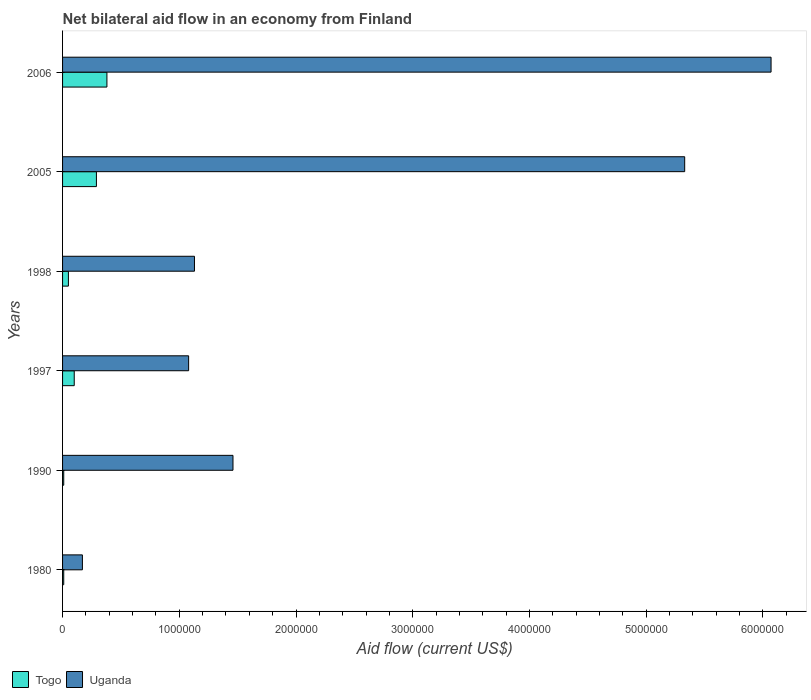How many bars are there on the 3rd tick from the bottom?
Ensure brevity in your answer.  2. What is the label of the 2nd group of bars from the top?
Give a very brief answer. 2005. In which year was the net bilateral aid flow in Uganda maximum?
Offer a terse response. 2006. In which year was the net bilateral aid flow in Togo minimum?
Offer a terse response. 1980. What is the total net bilateral aid flow in Togo in the graph?
Offer a very short reply. 8.40e+05. What is the difference between the net bilateral aid flow in Uganda in 1980 and that in 2005?
Keep it short and to the point. -5.16e+06. What is the average net bilateral aid flow in Uganda per year?
Your answer should be very brief. 2.54e+06. In the year 2005, what is the difference between the net bilateral aid flow in Uganda and net bilateral aid flow in Togo?
Provide a short and direct response. 5.04e+06. What is the ratio of the net bilateral aid flow in Togo in 1998 to that in 2005?
Give a very brief answer. 0.17. Is the net bilateral aid flow in Uganda in 1980 less than that in 1990?
Provide a succinct answer. Yes. Is the difference between the net bilateral aid flow in Uganda in 1997 and 2006 greater than the difference between the net bilateral aid flow in Togo in 1997 and 2006?
Provide a succinct answer. No. What is the difference between the highest and the second highest net bilateral aid flow in Uganda?
Give a very brief answer. 7.40e+05. What is the difference between the highest and the lowest net bilateral aid flow in Togo?
Offer a very short reply. 3.70e+05. Is the sum of the net bilateral aid flow in Togo in 1980 and 2005 greater than the maximum net bilateral aid flow in Uganda across all years?
Your answer should be very brief. No. What does the 1st bar from the top in 1990 represents?
Make the answer very short. Uganda. What does the 2nd bar from the bottom in 1998 represents?
Keep it short and to the point. Uganda. How many years are there in the graph?
Offer a terse response. 6. What is the difference between two consecutive major ticks on the X-axis?
Offer a very short reply. 1.00e+06. Does the graph contain any zero values?
Offer a very short reply. No. Where does the legend appear in the graph?
Ensure brevity in your answer.  Bottom left. How many legend labels are there?
Your answer should be very brief. 2. What is the title of the graph?
Ensure brevity in your answer.  Net bilateral aid flow in an economy from Finland. What is the label or title of the X-axis?
Your answer should be compact. Aid flow (current US$). What is the Aid flow (current US$) of Uganda in 1980?
Offer a very short reply. 1.70e+05. What is the Aid flow (current US$) in Togo in 1990?
Give a very brief answer. 10000. What is the Aid flow (current US$) in Uganda in 1990?
Make the answer very short. 1.46e+06. What is the Aid flow (current US$) of Uganda in 1997?
Your response must be concise. 1.08e+06. What is the Aid flow (current US$) of Togo in 1998?
Your answer should be compact. 5.00e+04. What is the Aid flow (current US$) of Uganda in 1998?
Your response must be concise. 1.13e+06. What is the Aid flow (current US$) in Togo in 2005?
Keep it short and to the point. 2.90e+05. What is the Aid flow (current US$) of Uganda in 2005?
Your answer should be compact. 5.33e+06. What is the Aid flow (current US$) of Togo in 2006?
Offer a very short reply. 3.80e+05. What is the Aid flow (current US$) of Uganda in 2006?
Ensure brevity in your answer.  6.07e+06. Across all years, what is the maximum Aid flow (current US$) of Uganda?
Offer a terse response. 6.07e+06. What is the total Aid flow (current US$) of Togo in the graph?
Provide a succinct answer. 8.40e+05. What is the total Aid flow (current US$) of Uganda in the graph?
Your answer should be very brief. 1.52e+07. What is the difference between the Aid flow (current US$) in Togo in 1980 and that in 1990?
Offer a terse response. 0. What is the difference between the Aid flow (current US$) in Uganda in 1980 and that in 1990?
Provide a short and direct response. -1.29e+06. What is the difference between the Aid flow (current US$) in Togo in 1980 and that in 1997?
Provide a short and direct response. -9.00e+04. What is the difference between the Aid flow (current US$) of Uganda in 1980 and that in 1997?
Ensure brevity in your answer.  -9.10e+05. What is the difference between the Aid flow (current US$) of Uganda in 1980 and that in 1998?
Give a very brief answer. -9.60e+05. What is the difference between the Aid flow (current US$) in Togo in 1980 and that in 2005?
Give a very brief answer. -2.80e+05. What is the difference between the Aid flow (current US$) in Uganda in 1980 and that in 2005?
Your answer should be very brief. -5.16e+06. What is the difference between the Aid flow (current US$) of Togo in 1980 and that in 2006?
Make the answer very short. -3.70e+05. What is the difference between the Aid flow (current US$) in Uganda in 1980 and that in 2006?
Your answer should be very brief. -5.90e+06. What is the difference between the Aid flow (current US$) of Uganda in 1990 and that in 1997?
Your response must be concise. 3.80e+05. What is the difference between the Aid flow (current US$) of Togo in 1990 and that in 1998?
Your answer should be compact. -4.00e+04. What is the difference between the Aid flow (current US$) in Uganda in 1990 and that in 1998?
Make the answer very short. 3.30e+05. What is the difference between the Aid flow (current US$) of Togo in 1990 and that in 2005?
Your answer should be compact. -2.80e+05. What is the difference between the Aid flow (current US$) of Uganda in 1990 and that in 2005?
Provide a short and direct response. -3.87e+06. What is the difference between the Aid flow (current US$) in Togo in 1990 and that in 2006?
Offer a very short reply. -3.70e+05. What is the difference between the Aid flow (current US$) of Uganda in 1990 and that in 2006?
Your response must be concise. -4.61e+06. What is the difference between the Aid flow (current US$) of Uganda in 1997 and that in 1998?
Ensure brevity in your answer.  -5.00e+04. What is the difference between the Aid flow (current US$) of Uganda in 1997 and that in 2005?
Provide a short and direct response. -4.25e+06. What is the difference between the Aid flow (current US$) in Togo in 1997 and that in 2006?
Ensure brevity in your answer.  -2.80e+05. What is the difference between the Aid flow (current US$) in Uganda in 1997 and that in 2006?
Your answer should be compact. -4.99e+06. What is the difference between the Aid flow (current US$) in Uganda in 1998 and that in 2005?
Provide a short and direct response. -4.20e+06. What is the difference between the Aid flow (current US$) of Togo in 1998 and that in 2006?
Give a very brief answer. -3.30e+05. What is the difference between the Aid flow (current US$) in Uganda in 1998 and that in 2006?
Keep it short and to the point. -4.94e+06. What is the difference between the Aid flow (current US$) of Togo in 2005 and that in 2006?
Provide a succinct answer. -9.00e+04. What is the difference between the Aid flow (current US$) in Uganda in 2005 and that in 2006?
Offer a very short reply. -7.40e+05. What is the difference between the Aid flow (current US$) in Togo in 1980 and the Aid flow (current US$) in Uganda in 1990?
Offer a terse response. -1.45e+06. What is the difference between the Aid flow (current US$) in Togo in 1980 and the Aid flow (current US$) in Uganda in 1997?
Provide a succinct answer. -1.07e+06. What is the difference between the Aid flow (current US$) in Togo in 1980 and the Aid flow (current US$) in Uganda in 1998?
Offer a terse response. -1.12e+06. What is the difference between the Aid flow (current US$) of Togo in 1980 and the Aid flow (current US$) of Uganda in 2005?
Your answer should be compact. -5.32e+06. What is the difference between the Aid flow (current US$) of Togo in 1980 and the Aid flow (current US$) of Uganda in 2006?
Keep it short and to the point. -6.06e+06. What is the difference between the Aid flow (current US$) in Togo in 1990 and the Aid flow (current US$) in Uganda in 1997?
Give a very brief answer. -1.07e+06. What is the difference between the Aid flow (current US$) of Togo in 1990 and the Aid flow (current US$) of Uganda in 1998?
Offer a very short reply. -1.12e+06. What is the difference between the Aid flow (current US$) in Togo in 1990 and the Aid flow (current US$) in Uganda in 2005?
Your response must be concise. -5.32e+06. What is the difference between the Aid flow (current US$) in Togo in 1990 and the Aid flow (current US$) in Uganda in 2006?
Give a very brief answer. -6.06e+06. What is the difference between the Aid flow (current US$) in Togo in 1997 and the Aid flow (current US$) in Uganda in 1998?
Provide a succinct answer. -1.03e+06. What is the difference between the Aid flow (current US$) of Togo in 1997 and the Aid flow (current US$) of Uganda in 2005?
Your answer should be very brief. -5.23e+06. What is the difference between the Aid flow (current US$) of Togo in 1997 and the Aid flow (current US$) of Uganda in 2006?
Provide a short and direct response. -5.97e+06. What is the difference between the Aid flow (current US$) of Togo in 1998 and the Aid flow (current US$) of Uganda in 2005?
Your answer should be compact. -5.28e+06. What is the difference between the Aid flow (current US$) of Togo in 1998 and the Aid flow (current US$) of Uganda in 2006?
Ensure brevity in your answer.  -6.02e+06. What is the difference between the Aid flow (current US$) of Togo in 2005 and the Aid flow (current US$) of Uganda in 2006?
Provide a succinct answer. -5.78e+06. What is the average Aid flow (current US$) of Togo per year?
Your answer should be compact. 1.40e+05. What is the average Aid flow (current US$) of Uganda per year?
Your answer should be compact. 2.54e+06. In the year 1990, what is the difference between the Aid flow (current US$) of Togo and Aid flow (current US$) of Uganda?
Your response must be concise. -1.45e+06. In the year 1997, what is the difference between the Aid flow (current US$) of Togo and Aid flow (current US$) of Uganda?
Provide a succinct answer. -9.80e+05. In the year 1998, what is the difference between the Aid flow (current US$) of Togo and Aid flow (current US$) of Uganda?
Your response must be concise. -1.08e+06. In the year 2005, what is the difference between the Aid flow (current US$) in Togo and Aid flow (current US$) in Uganda?
Your answer should be compact. -5.04e+06. In the year 2006, what is the difference between the Aid flow (current US$) in Togo and Aid flow (current US$) in Uganda?
Ensure brevity in your answer.  -5.69e+06. What is the ratio of the Aid flow (current US$) of Togo in 1980 to that in 1990?
Make the answer very short. 1. What is the ratio of the Aid flow (current US$) of Uganda in 1980 to that in 1990?
Your answer should be compact. 0.12. What is the ratio of the Aid flow (current US$) in Togo in 1980 to that in 1997?
Offer a very short reply. 0.1. What is the ratio of the Aid flow (current US$) of Uganda in 1980 to that in 1997?
Provide a succinct answer. 0.16. What is the ratio of the Aid flow (current US$) in Togo in 1980 to that in 1998?
Your response must be concise. 0.2. What is the ratio of the Aid flow (current US$) of Uganda in 1980 to that in 1998?
Provide a short and direct response. 0.15. What is the ratio of the Aid flow (current US$) in Togo in 1980 to that in 2005?
Give a very brief answer. 0.03. What is the ratio of the Aid flow (current US$) of Uganda in 1980 to that in 2005?
Keep it short and to the point. 0.03. What is the ratio of the Aid flow (current US$) in Togo in 1980 to that in 2006?
Your answer should be very brief. 0.03. What is the ratio of the Aid flow (current US$) in Uganda in 1980 to that in 2006?
Make the answer very short. 0.03. What is the ratio of the Aid flow (current US$) of Uganda in 1990 to that in 1997?
Offer a terse response. 1.35. What is the ratio of the Aid flow (current US$) in Togo in 1990 to that in 1998?
Your answer should be very brief. 0.2. What is the ratio of the Aid flow (current US$) of Uganda in 1990 to that in 1998?
Your answer should be very brief. 1.29. What is the ratio of the Aid flow (current US$) in Togo in 1990 to that in 2005?
Ensure brevity in your answer.  0.03. What is the ratio of the Aid flow (current US$) of Uganda in 1990 to that in 2005?
Give a very brief answer. 0.27. What is the ratio of the Aid flow (current US$) of Togo in 1990 to that in 2006?
Keep it short and to the point. 0.03. What is the ratio of the Aid flow (current US$) of Uganda in 1990 to that in 2006?
Ensure brevity in your answer.  0.24. What is the ratio of the Aid flow (current US$) of Togo in 1997 to that in 1998?
Offer a very short reply. 2. What is the ratio of the Aid flow (current US$) in Uganda in 1997 to that in 1998?
Provide a short and direct response. 0.96. What is the ratio of the Aid flow (current US$) of Togo in 1997 to that in 2005?
Keep it short and to the point. 0.34. What is the ratio of the Aid flow (current US$) of Uganda in 1997 to that in 2005?
Make the answer very short. 0.2. What is the ratio of the Aid flow (current US$) of Togo in 1997 to that in 2006?
Provide a succinct answer. 0.26. What is the ratio of the Aid flow (current US$) in Uganda in 1997 to that in 2006?
Offer a very short reply. 0.18. What is the ratio of the Aid flow (current US$) of Togo in 1998 to that in 2005?
Offer a terse response. 0.17. What is the ratio of the Aid flow (current US$) in Uganda in 1998 to that in 2005?
Give a very brief answer. 0.21. What is the ratio of the Aid flow (current US$) of Togo in 1998 to that in 2006?
Offer a very short reply. 0.13. What is the ratio of the Aid flow (current US$) of Uganda in 1998 to that in 2006?
Offer a very short reply. 0.19. What is the ratio of the Aid flow (current US$) in Togo in 2005 to that in 2006?
Your response must be concise. 0.76. What is the ratio of the Aid flow (current US$) in Uganda in 2005 to that in 2006?
Offer a terse response. 0.88. What is the difference between the highest and the second highest Aid flow (current US$) in Uganda?
Offer a very short reply. 7.40e+05. What is the difference between the highest and the lowest Aid flow (current US$) of Togo?
Provide a short and direct response. 3.70e+05. What is the difference between the highest and the lowest Aid flow (current US$) of Uganda?
Make the answer very short. 5.90e+06. 